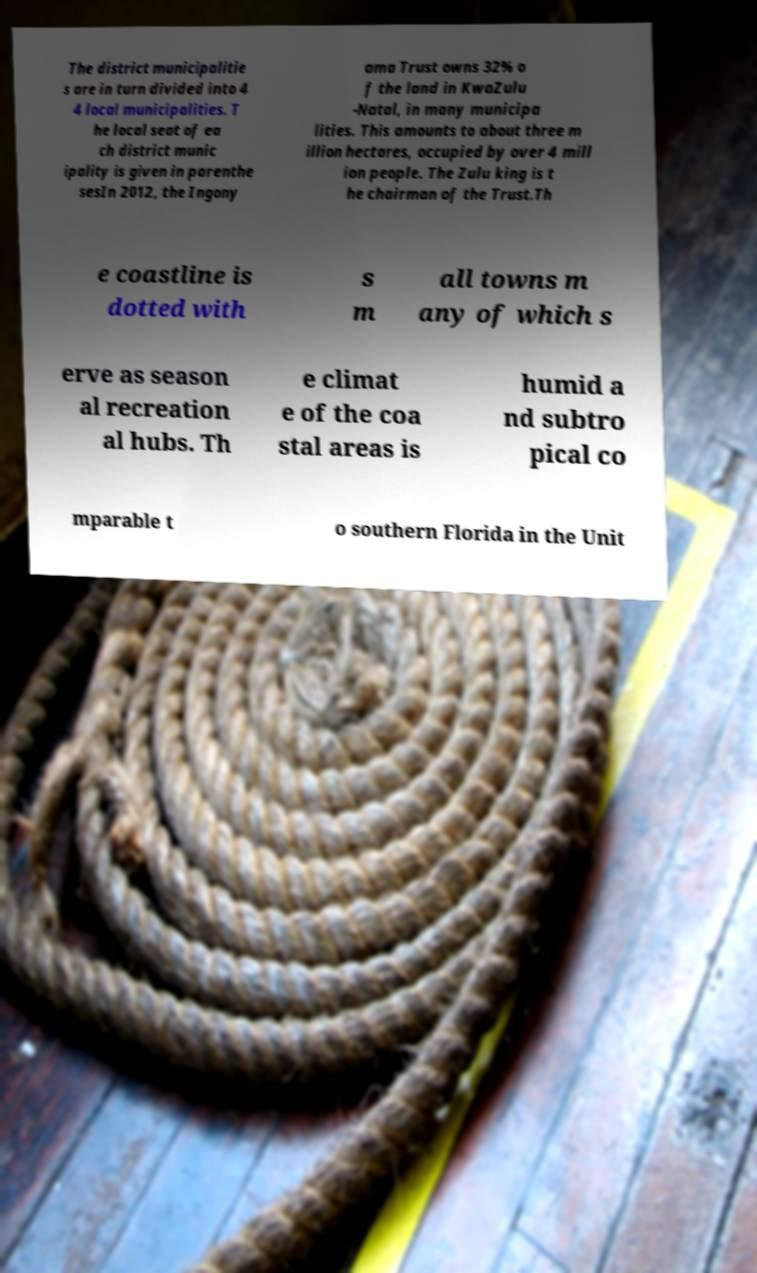There's text embedded in this image that I need extracted. Can you transcribe it verbatim? The district municipalitie s are in turn divided into 4 4 local municipalities. T he local seat of ea ch district munic ipality is given in parenthe sesIn 2012, the Ingony ama Trust owns 32% o f the land in KwaZulu -Natal, in many municipa lities. This amounts to about three m illion hectares, occupied by over 4 mill ion people. The Zulu king is t he chairman of the Trust.Th e coastline is dotted with s m all towns m any of which s erve as season al recreation al hubs. Th e climat e of the coa stal areas is humid a nd subtro pical co mparable t o southern Florida in the Unit 